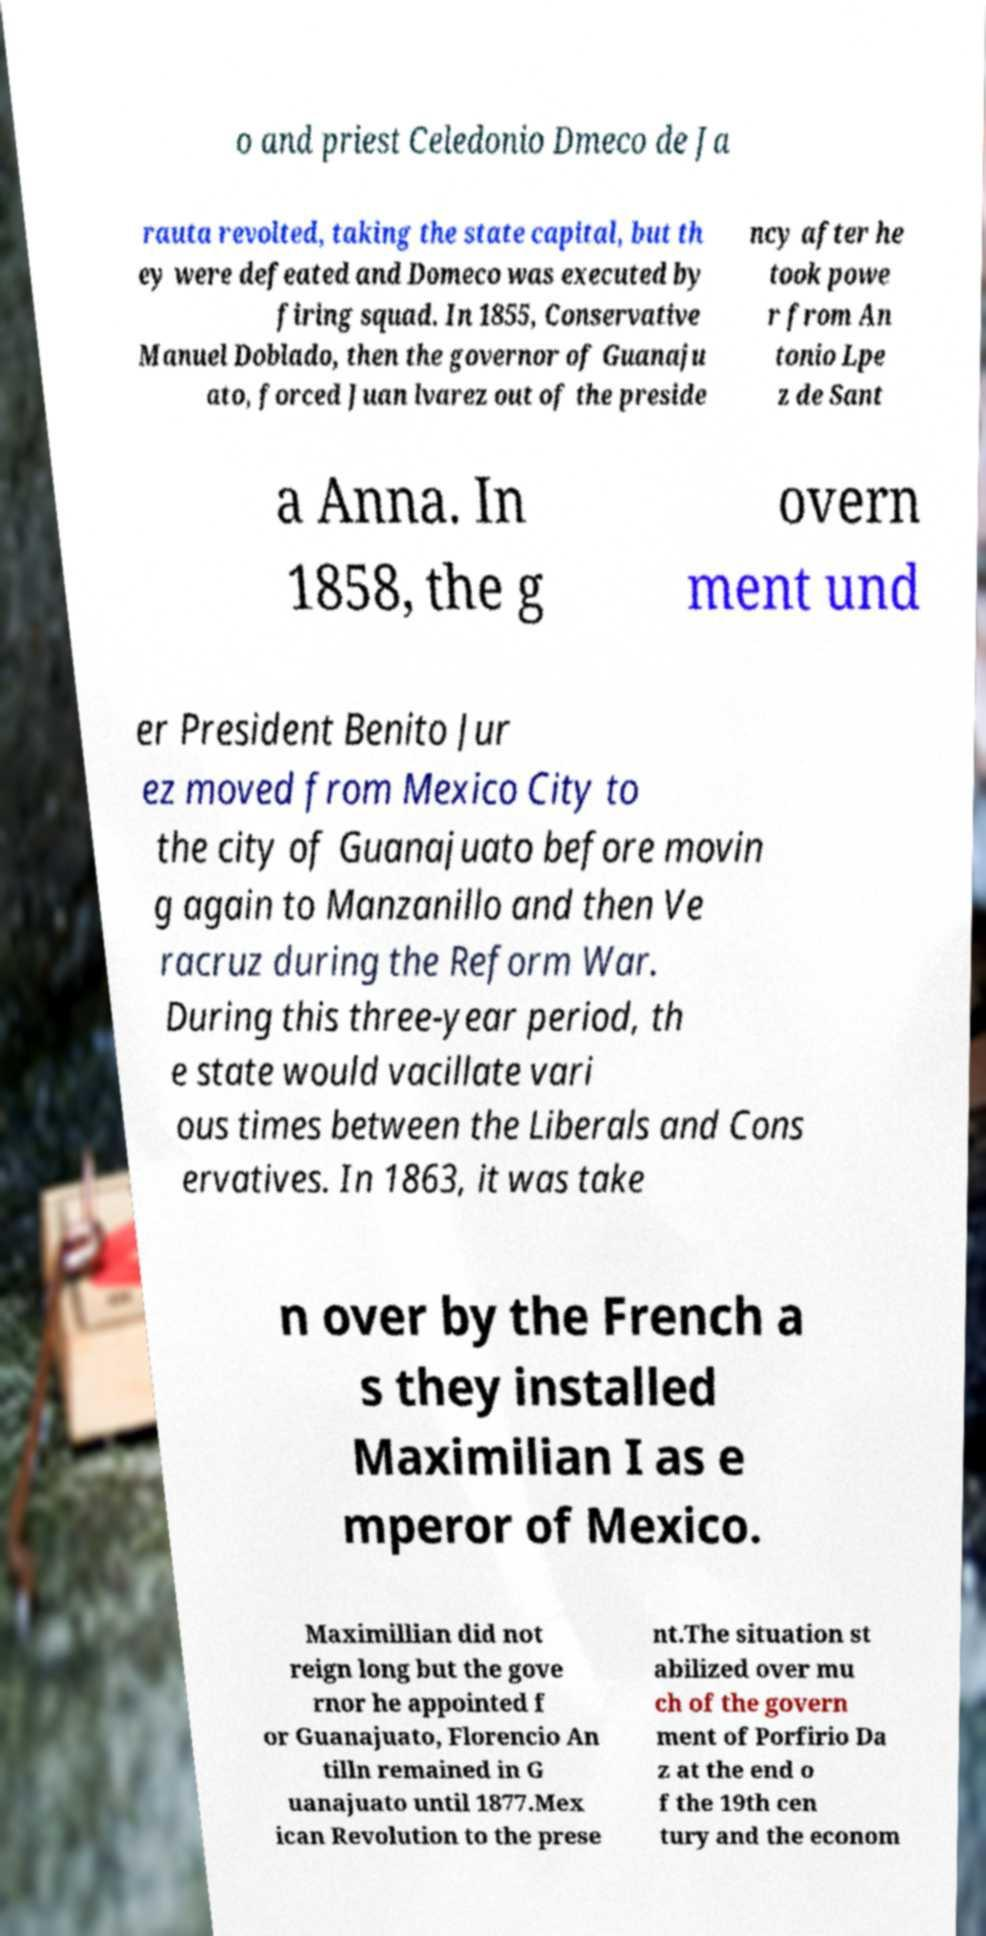Can you accurately transcribe the text from the provided image for me? o and priest Celedonio Dmeco de Ja rauta revolted, taking the state capital, but th ey were defeated and Domeco was executed by firing squad. In 1855, Conservative Manuel Doblado, then the governor of Guanaju ato, forced Juan lvarez out of the preside ncy after he took powe r from An tonio Lpe z de Sant a Anna. In 1858, the g overn ment und er President Benito Jur ez moved from Mexico City to the city of Guanajuato before movin g again to Manzanillo and then Ve racruz during the Reform War. During this three-year period, th e state would vacillate vari ous times between the Liberals and Cons ervatives. In 1863, it was take n over by the French a s they installed Maximilian I as e mperor of Mexico. Maximillian did not reign long but the gove rnor he appointed f or Guanajuato, Florencio An tilln remained in G uanajuato until 1877.Mex ican Revolution to the prese nt.The situation st abilized over mu ch of the govern ment of Porfirio Da z at the end o f the 19th cen tury and the econom 